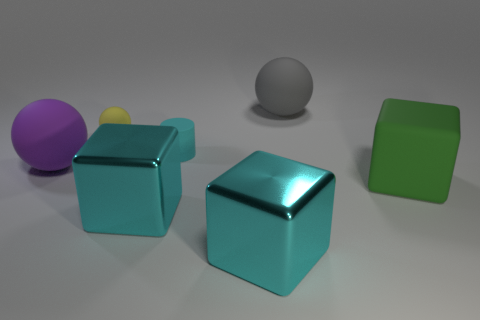Is there a small yellow object made of the same material as the cylinder?
Your answer should be compact. Yes. What is the color of the block that is to the right of the cyan shiny object to the right of the large cube that is to the left of the tiny cyan object?
Ensure brevity in your answer.  Green. Are the big ball that is behind the purple matte sphere and the cyan thing behind the green rubber object made of the same material?
Your response must be concise. Yes. The cyan thing left of the cylinder has what shape?
Give a very brief answer. Cube. How many things are green cylinders or large cyan metal objects to the right of the cyan cylinder?
Make the answer very short. 1. Are there the same number of big purple matte objects that are on the right side of the big green block and tiny cyan matte things on the left side of the yellow ball?
Offer a very short reply. Yes. There is a small cylinder; how many large rubber balls are in front of it?
Your answer should be very brief. 1. What number of things are big gray matte spheres or tiny yellow matte objects?
Your answer should be very brief. 2. What number of cyan shiny cubes have the same size as the cyan cylinder?
Offer a terse response. 0. The green object that is right of the cyan object behind the large green rubber thing is what shape?
Ensure brevity in your answer.  Cube. 